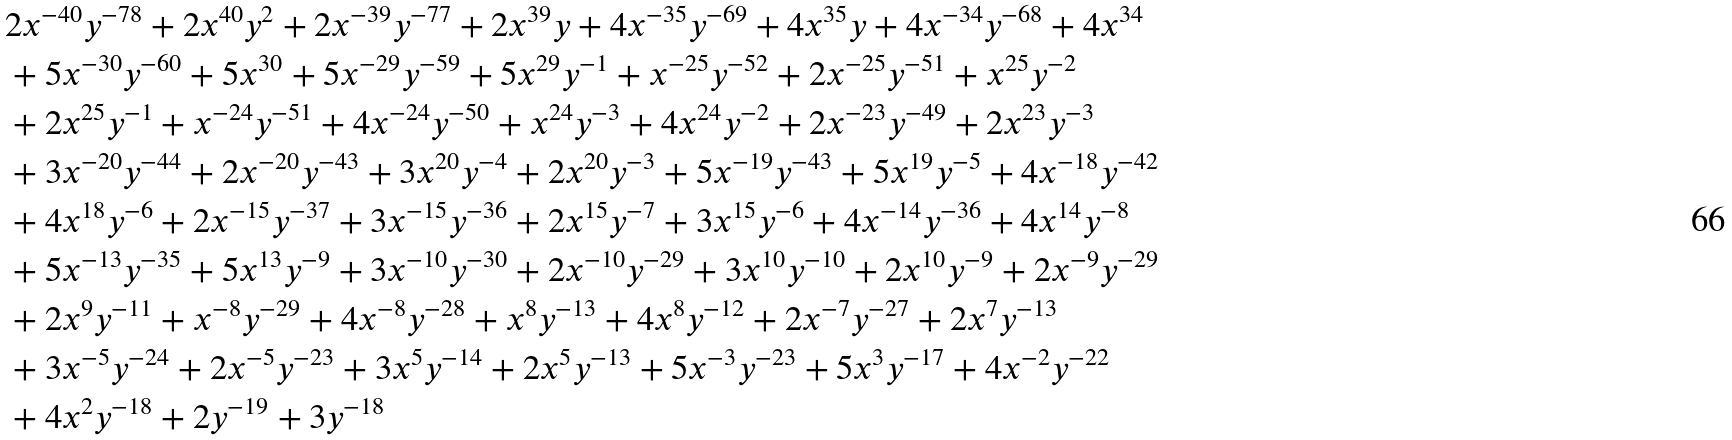Convert formula to latex. <formula><loc_0><loc_0><loc_500><loc_500>& 2 x ^ { - 4 0 } y ^ { - 7 8 } + 2 x ^ { 4 0 } y ^ { 2 } + 2 x ^ { - 3 9 } y ^ { - 7 7 } + 2 x ^ { 3 9 } y + 4 x ^ { - 3 5 } y ^ { - 6 9 } + 4 x ^ { 3 5 } y + 4 x ^ { - 3 4 } y ^ { - 6 8 } + 4 x ^ { 3 4 } \\ & + 5 x ^ { - 3 0 } y ^ { - 6 0 } + 5 x ^ { 3 0 } + 5 x ^ { - 2 9 } y ^ { - 5 9 } + 5 x ^ { 2 9 } y ^ { - 1 } + x ^ { - 2 5 } y ^ { - 5 2 } + 2 x ^ { - 2 5 } y ^ { - 5 1 } + x ^ { 2 5 } y ^ { - 2 } \\ & + 2 x ^ { 2 5 } y ^ { - 1 } + x ^ { - 2 4 } y ^ { - 5 1 } + 4 x ^ { - 2 4 } y ^ { - 5 0 } + x ^ { 2 4 } y ^ { - 3 } + 4 x ^ { 2 4 } y ^ { - 2 } + 2 x ^ { - 2 3 } y ^ { - 4 9 } + 2 x ^ { 2 3 } y ^ { - 3 } \\ & + 3 x ^ { - 2 0 } y ^ { - 4 4 } + 2 x ^ { - 2 0 } y ^ { - 4 3 } + 3 x ^ { 2 0 } y ^ { - 4 } + 2 x ^ { 2 0 } y ^ { - 3 } + 5 x ^ { - 1 9 } y ^ { - 4 3 } + 5 x ^ { 1 9 } y ^ { - 5 } + 4 x ^ { - 1 8 } y ^ { - 4 2 } \\ & + 4 x ^ { 1 8 } y ^ { - 6 } + 2 x ^ { - 1 5 } y ^ { - 3 7 } + 3 x ^ { - 1 5 } y ^ { - 3 6 } + 2 x ^ { 1 5 } y ^ { - 7 } + 3 x ^ { 1 5 } y ^ { - 6 } + 4 x ^ { - 1 4 } y ^ { - 3 6 } + 4 x ^ { 1 4 } y ^ { - 8 } \\ & + 5 x ^ { - 1 3 } y ^ { - 3 5 } + 5 x ^ { 1 3 } y ^ { - 9 } + 3 x ^ { - 1 0 } y ^ { - 3 0 } + 2 x ^ { - 1 0 } y ^ { - 2 9 } + 3 x ^ { 1 0 } y ^ { - 1 0 } + 2 x ^ { 1 0 } y ^ { - 9 } + 2 x ^ { - 9 } y ^ { - 2 9 } \\ & + 2 x ^ { 9 } y ^ { - 1 1 } + x ^ { - 8 } y ^ { - 2 9 } + 4 x ^ { - 8 } y ^ { - 2 8 } + x ^ { 8 } y ^ { - 1 3 } + 4 x ^ { 8 } y ^ { - 1 2 } + 2 x ^ { - 7 } y ^ { - 2 7 } + 2 x ^ { 7 } y ^ { - 1 3 } \\ & + 3 x ^ { - 5 } y ^ { - 2 4 } + 2 x ^ { - 5 } y ^ { - 2 3 } + 3 x ^ { 5 } y ^ { - 1 4 } + 2 x ^ { 5 } y ^ { - 1 3 } + 5 x ^ { - 3 } y ^ { - 2 3 } + 5 x ^ { 3 } y ^ { - 1 7 } + 4 x ^ { - 2 } y ^ { - 2 2 } \\ & + 4 x ^ { 2 } y ^ { - 1 8 } + 2 y ^ { - 1 9 } + 3 y ^ { - 1 8 }</formula> 